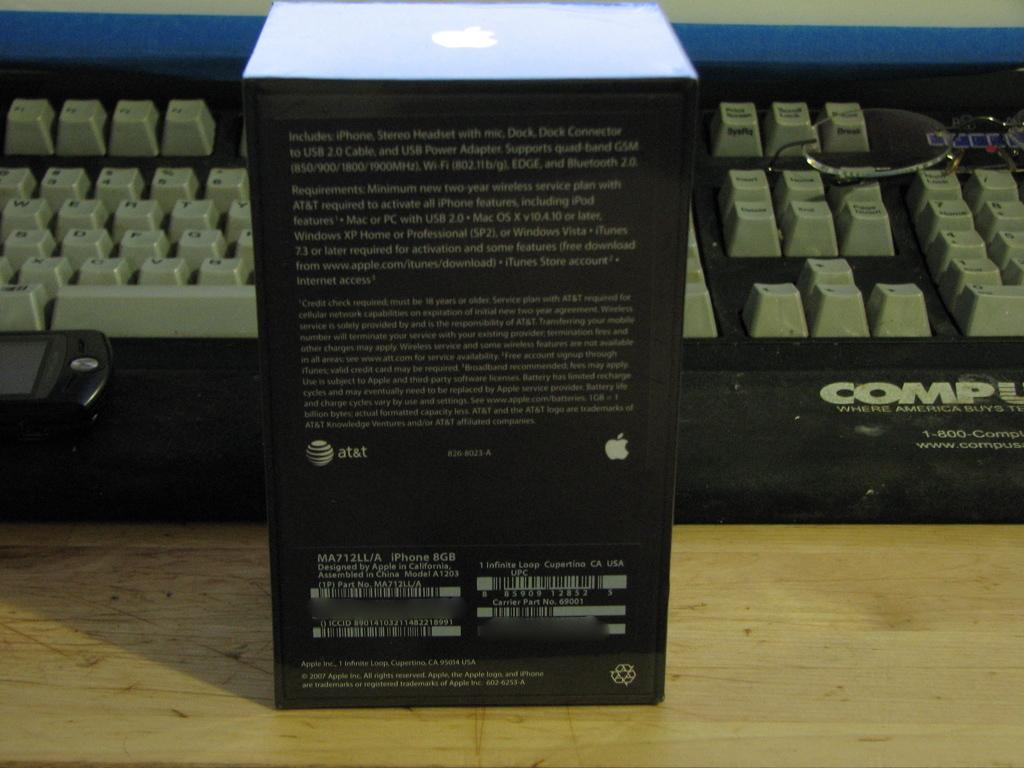<image>
Relay a brief, clear account of the picture shown. A keyboard is behind a box that includes an Iphone, Stereo Headset with mic, Dock,  and Dock Connector. 